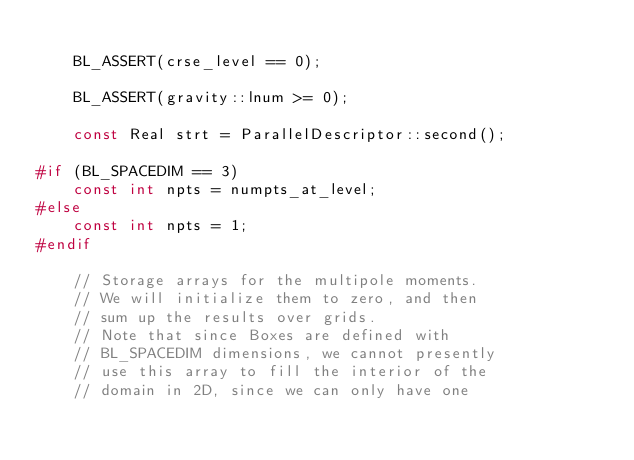<code> <loc_0><loc_0><loc_500><loc_500><_C++_>
    BL_ASSERT(crse_level == 0);

    BL_ASSERT(gravity::lnum >= 0);

    const Real strt = ParallelDescriptor::second();

#if (BL_SPACEDIM == 3)
    const int npts = numpts_at_level;
#else
    const int npts = 1;
#endif

    // Storage arrays for the multipole moments.
    // We will initialize them to zero, and then
    // sum up the results over grids.
    // Note that since Boxes are defined with
    // BL_SPACEDIM dimensions, we cannot presently
    // use this array to fill the interior of the
    // domain in 2D, since we can only have one</code> 